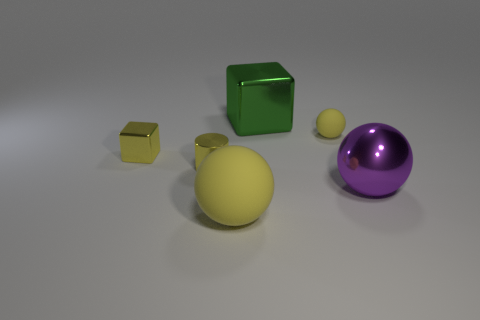Subtract all yellow rubber spheres. How many spheres are left? 1 Add 4 red metallic blocks. How many objects exist? 10 Subtract all cylinders. How many objects are left? 5 Subtract 1 yellow cubes. How many objects are left? 5 Subtract 1 spheres. How many spheres are left? 2 Subtract all brown cylinders. Subtract all cyan blocks. How many cylinders are left? 1 Subtract all blue cylinders. How many gray spheres are left? 0 Subtract all big blue rubber cylinders. Subtract all tiny yellow shiny cylinders. How many objects are left? 5 Add 1 large yellow things. How many large yellow things are left? 2 Add 5 tiny yellow metal things. How many tiny yellow metal things exist? 7 